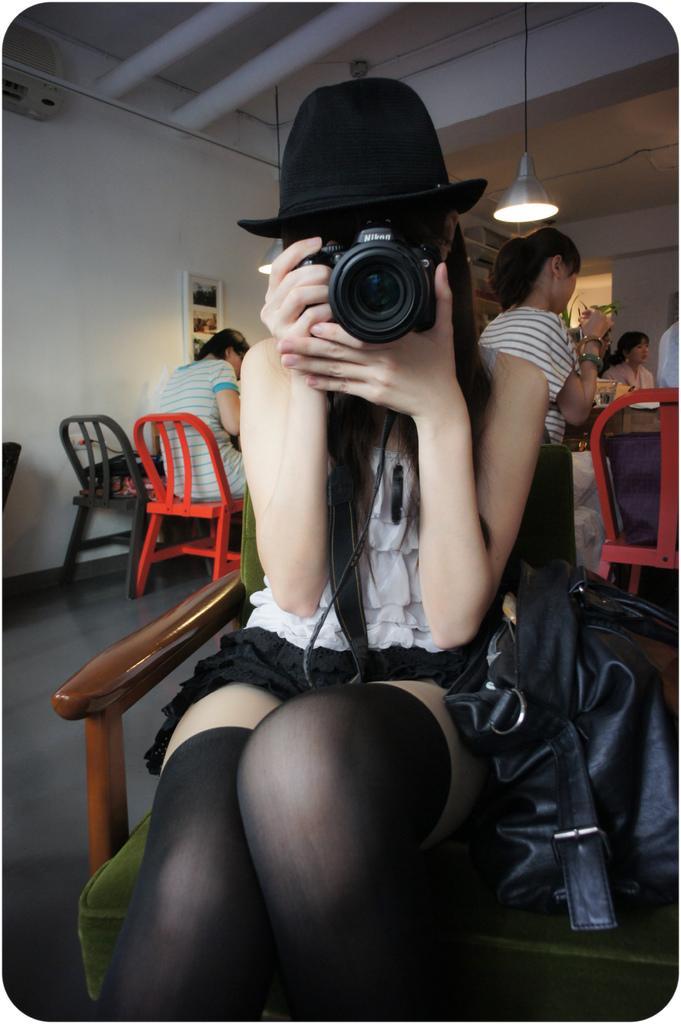Can you describe this image briefly? In this image we can see a lady sitting and holding a camera, next to her there is a bag placed on the chair. In the background there are people sitting and we can see a light. There is a wall and we can see a frame placed on the wall. 